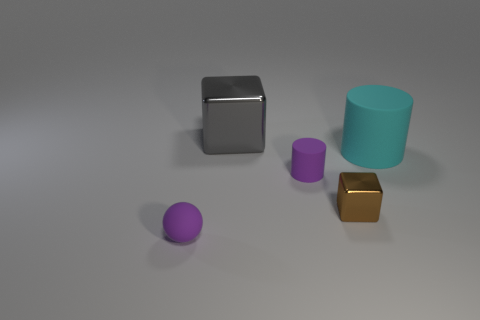Add 3 metallic blocks. How many objects exist? 8 Subtract all spheres. How many objects are left? 4 Add 3 tiny brown cubes. How many tiny brown cubes are left? 4 Add 2 big green objects. How many big green objects exist? 2 Subtract 0 purple cubes. How many objects are left? 5 Subtract all big cyan matte objects. Subtract all large gray objects. How many objects are left? 3 